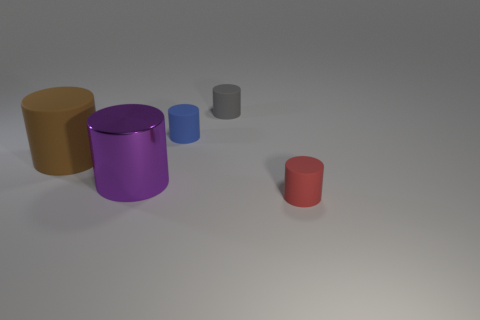Add 3 gray shiny cylinders. How many objects exist? 8 Subtract all metallic cylinders. How many cylinders are left? 4 Subtract 1 cylinders. How many cylinders are left? 4 Add 1 gray matte objects. How many gray matte objects exist? 2 Subtract all red cylinders. How many cylinders are left? 4 Subtract 0 red spheres. How many objects are left? 5 Subtract all blue cylinders. Subtract all red spheres. How many cylinders are left? 4 Subtract all red cubes. How many cyan cylinders are left? 0 Subtract all tiny red matte objects. Subtract all small blue rubber objects. How many objects are left? 3 Add 4 big brown matte cylinders. How many big brown matte cylinders are left? 5 